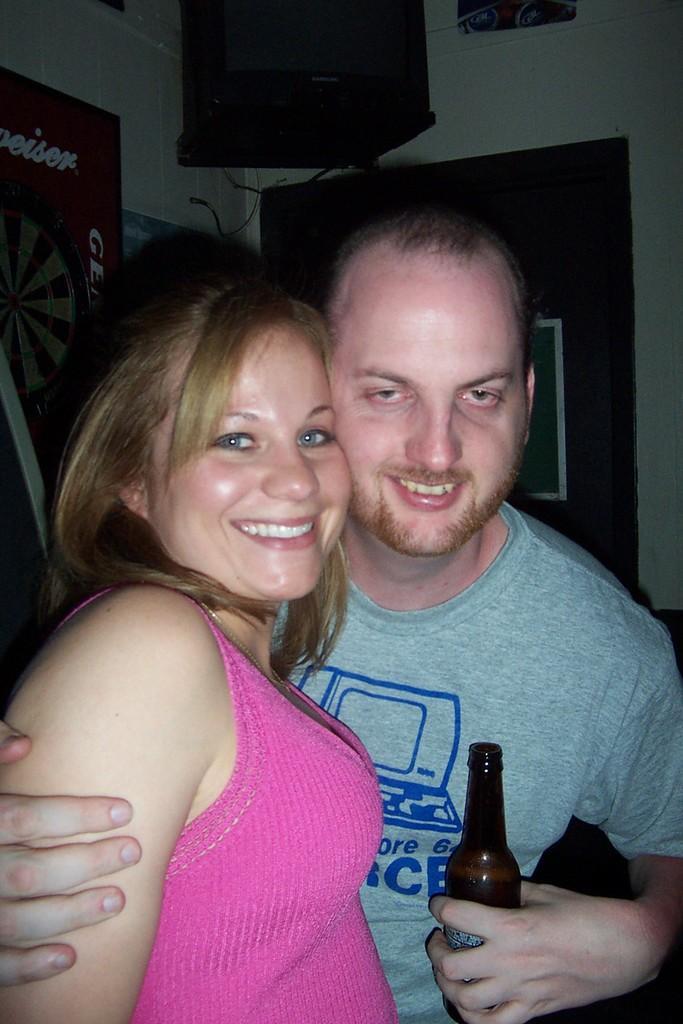Could you give a brief overview of what you see in this image? These two persons are standing and smiling,this person holding bottle. On the background we can see wall,posters. 